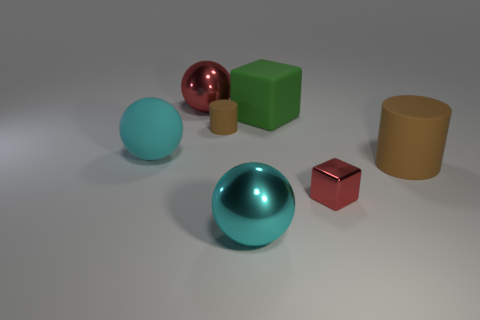Add 1 green matte blocks. How many objects exist? 8 Subtract all spheres. How many objects are left? 4 Subtract 1 green blocks. How many objects are left? 6 Subtract all cyan rubber spheres. Subtract all big blue rubber cubes. How many objects are left? 6 Add 1 green objects. How many green objects are left? 2 Add 2 large brown rubber cylinders. How many large brown rubber cylinders exist? 3 